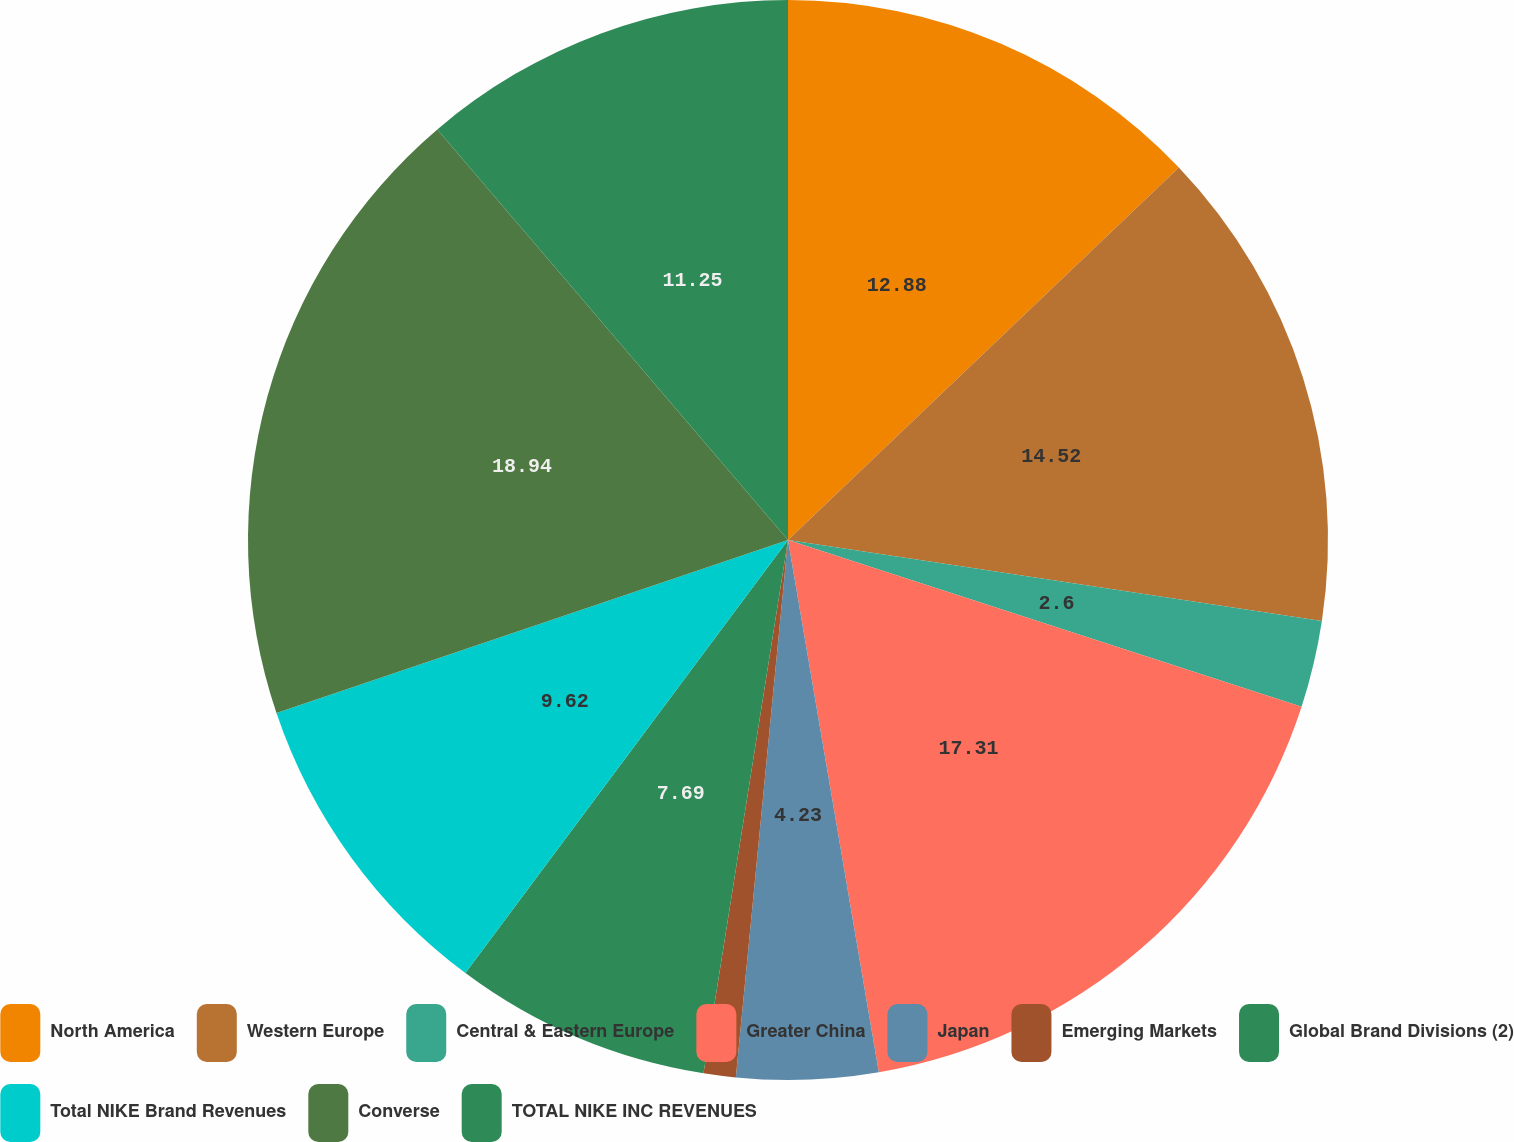Convert chart. <chart><loc_0><loc_0><loc_500><loc_500><pie_chart><fcel>North America<fcel>Western Europe<fcel>Central & Eastern Europe<fcel>Greater China<fcel>Japan<fcel>Emerging Markets<fcel>Global Brand Divisions (2)<fcel>Total NIKE Brand Revenues<fcel>Converse<fcel>TOTAL NIKE INC REVENUES<nl><fcel>12.88%<fcel>14.52%<fcel>2.6%<fcel>17.31%<fcel>4.23%<fcel>0.96%<fcel>7.69%<fcel>9.62%<fcel>18.94%<fcel>11.25%<nl></chart> 